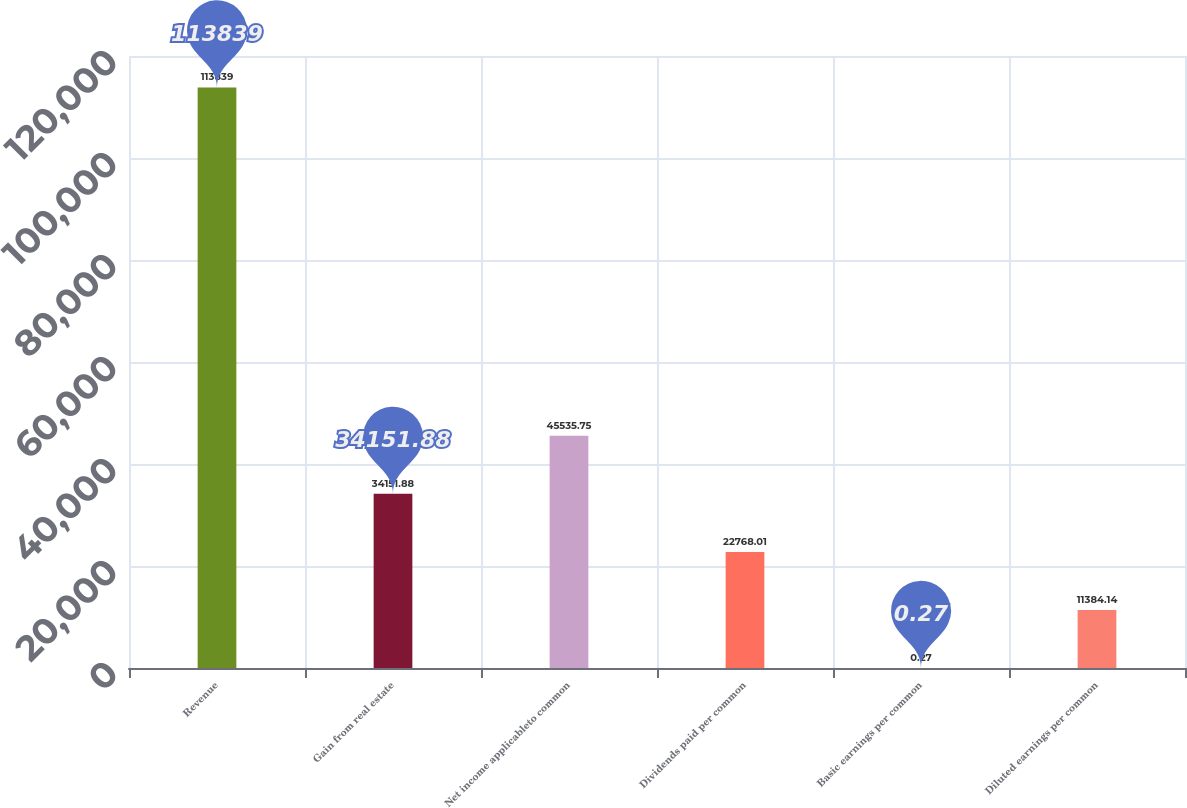<chart> <loc_0><loc_0><loc_500><loc_500><bar_chart><fcel>Revenue<fcel>Gain from real estate<fcel>Net income applicableto common<fcel>Dividends paid per common<fcel>Basic earnings per common<fcel>Diluted earnings per common<nl><fcel>113839<fcel>34151.9<fcel>45535.8<fcel>22768<fcel>0.27<fcel>11384.1<nl></chart> 